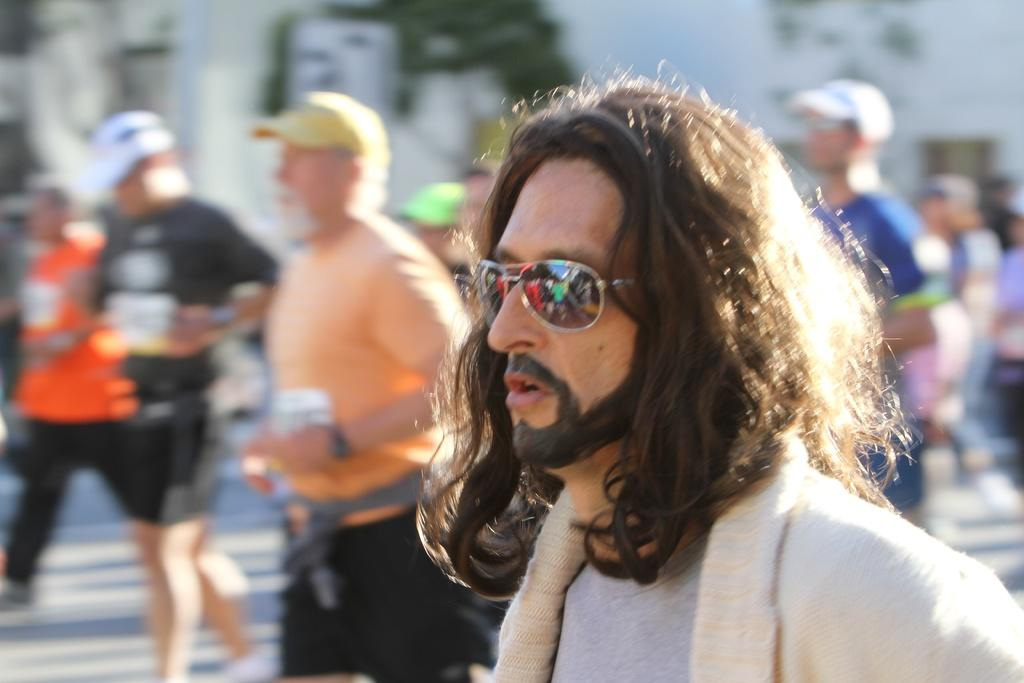How many people are in the image? There is a group of people in the image. What are some of the people in the image doing? Some people are walking on the road. Can you describe the appearance of one of the individuals in the image? There is a man wearing goggles. What can be said about the background of the image? The background of the image is blurry. How many balls can be seen in the image? There are no balls present in the image. What type of goose is visible in the image? There are no geese present in the image. 